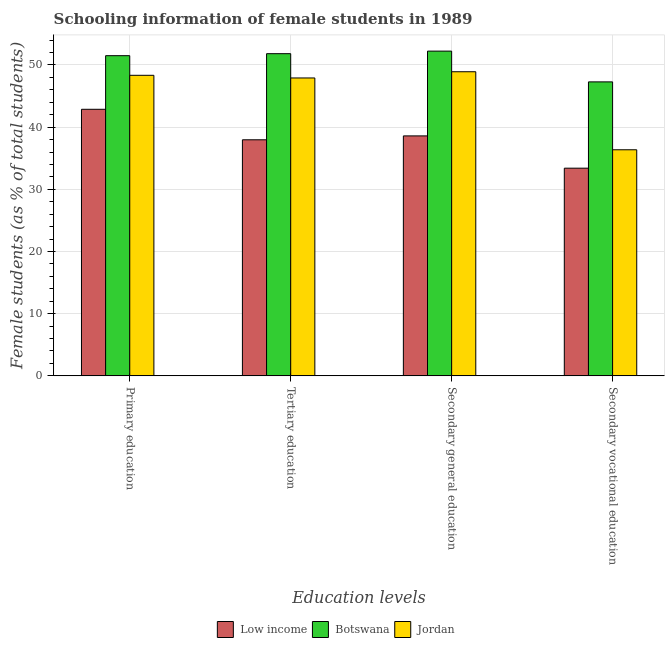How many different coloured bars are there?
Provide a short and direct response. 3. Are the number of bars per tick equal to the number of legend labels?
Offer a terse response. Yes. How many bars are there on the 1st tick from the left?
Your response must be concise. 3. How many bars are there on the 1st tick from the right?
Keep it short and to the point. 3. What is the percentage of female students in secondary education in Low income?
Offer a very short reply. 38.59. Across all countries, what is the maximum percentage of female students in secondary education?
Make the answer very short. 52.23. Across all countries, what is the minimum percentage of female students in secondary education?
Ensure brevity in your answer.  38.59. In which country was the percentage of female students in primary education maximum?
Give a very brief answer. Botswana. In which country was the percentage of female students in primary education minimum?
Your answer should be compact. Low income. What is the total percentage of female students in secondary education in the graph?
Ensure brevity in your answer.  139.73. What is the difference between the percentage of female students in primary education in Low income and that in Botswana?
Your response must be concise. -8.62. What is the difference between the percentage of female students in secondary vocational education in Botswana and the percentage of female students in primary education in Low income?
Give a very brief answer. 4.41. What is the average percentage of female students in secondary education per country?
Offer a very short reply. 46.58. What is the difference between the percentage of female students in secondary vocational education and percentage of female students in secondary education in Low income?
Your answer should be compact. -5.19. What is the ratio of the percentage of female students in secondary vocational education in Jordan to that in Low income?
Make the answer very short. 1.09. Is the percentage of female students in secondary vocational education in Botswana less than that in Jordan?
Offer a very short reply. No. What is the difference between the highest and the second highest percentage of female students in secondary vocational education?
Give a very brief answer. 10.92. What is the difference between the highest and the lowest percentage of female students in secondary vocational education?
Your response must be concise. 13.88. Is the sum of the percentage of female students in secondary education in Jordan and Botswana greater than the maximum percentage of female students in secondary vocational education across all countries?
Ensure brevity in your answer.  Yes. Is it the case that in every country, the sum of the percentage of female students in secondary education and percentage of female students in secondary vocational education is greater than the sum of percentage of female students in tertiary education and percentage of female students in primary education?
Keep it short and to the point. No. What does the 3rd bar from the left in Tertiary education represents?
Offer a very short reply. Jordan. How many countries are there in the graph?
Provide a short and direct response. 3. What is the difference between two consecutive major ticks on the Y-axis?
Offer a very short reply. 10. Does the graph contain any zero values?
Give a very brief answer. No. Does the graph contain grids?
Your answer should be very brief. Yes. Where does the legend appear in the graph?
Offer a terse response. Bottom center. How are the legend labels stacked?
Keep it short and to the point. Horizontal. What is the title of the graph?
Offer a very short reply. Schooling information of female students in 1989. Does "Djibouti" appear as one of the legend labels in the graph?
Give a very brief answer. No. What is the label or title of the X-axis?
Make the answer very short. Education levels. What is the label or title of the Y-axis?
Make the answer very short. Female students (as % of total students). What is the Female students (as % of total students) in Low income in Primary education?
Offer a very short reply. 42.87. What is the Female students (as % of total students) in Botswana in Primary education?
Offer a very short reply. 51.49. What is the Female students (as % of total students) of Jordan in Primary education?
Ensure brevity in your answer.  48.34. What is the Female students (as % of total students) of Low income in Tertiary education?
Make the answer very short. 37.97. What is the Female students (as % of total students) of Botswana in Tertiary education?
Your answer should be very brief. 51.81. What is the Female students (as % of total students) in Jordan in Tertiary education?
Your answer should be compact. 47.91. What is the Female students (as % of total students) in Low income in Secondary general education?
Provide a short and direct response. 38.59. What is the Female students (as % of total students) of Botswana in Secondary general education?
Keep it short and to the point. 52.23. What is the Female students (as % of total students) of Jordan in Secondary general education?
Ensure brevity in your answer.  48.91. What is the Female students (as % of total students) of Low income in Secondary vocational education?
Make the answer very short. 33.4. What is the Female students (as % of total students) of Botswana in Secondary vocational education?
Your answer should be very brief. 47.28. What is the Female students (as % of total students) of Jordan in Secondary vocational education?
Keep it short and to the point. 36.36. Across all Education levels, what is the maximum Female students (as % of total students) of Low income?
Make the answer very short. 42.87. Across all Education levels, what is the maximum Female students (as % of total students) in Botswana?
Keep it short and to the point. 52.23. Across all Education levels, what is the maximum Female students (as % of total students) in Jordan?
Provide a succinct answer. 48.91. Across all Education levels, what is the minimum Female students (as % of total students) in Low income?
Make the answer very short. 33.4. Across all Education levels, what is the minimum Female students (as % of total students) of Botswana?
Your response must be concise. 47.28. Across all Education levels, what is the minimum Female students (as % of total students) of Jordan?
Offer a terse response. 36.36. What is the total Female students (as % of total students) of Low income in the graph?
Your response must be concise. 152.83. What is the total Female students (as % of total students) of Botswana in the graph?
Make the answer very short. 202.81. What is the total Female students (as % of total students) in Jordan in the graph?
Give a very brief answer. 181.51. What is the difference between the Female students (as % of total students) in Low income in Primary education and that in Tertiary education?
Offer a very short reply. 4.91. What is the difference between the Female students (as % of total students) of Botswana in Primary education and that in Tertiary education?
Provide a succinct answer. -0.32. What is the difference between the Female students (as % of total students) in Jordan in Primary education and that in Tertiary education?
Make the answer very short. 0.43. What is the difference between the Female students (as % of total students) in Low income in Primary education and that in Secondary general education?
Keep it short and to the point. 4.28. What is the difference between the Female students (as % of total students) of Botswana in Primary education and that in Secondary general education?
Provide a short and direct response. -0.73. What is the difference between the Female students (as % of total students) of Jordan in Primary education and that in Secondary general education?
Make the answer very short. -0.57. What is the difference between the Female students (as % of total students) in Low income in Primary education and that in Secondary vocational education?
Provide a succinct answer. 9.47. What is the difference between the Female students (as % of total students) of Botswana in Primary education and that in Secondary vocational education?
Make the answer very short. 4.21. What is the difference between the Female students (as % of total students) in Jordan in Primary education and that in Secondary vocational education?
Give a very brief answer. 11.98. What is the difference between the Female students (as % of total students) in Low income in Tertiary education and that in Secondary general education?
Give a very brief answer. -0.63. What is the difference between the Female students (as % of total students) in Botswana in Tertiary education and that in Secondary general education?
Offer a very short reply. -0.41. What is the difference between the Female students (as % of total students) of Jordan in Tertiary education and that in Secondary general education?
Offer a very short reply. -1. What is the difference between the Female students (as % of total students) in Low income in Tertiary education and that in Secondary vocational education?
Provide a succinct answer. 4.57. What is the difference between the Female students (as % of total students) in Botswana in Tertiary education and that in Secondary vocational education?
Your answer should be compact. 4.54. What is the difference between the Female students (as % of total students) in Jordan in Tertiary education and that in Secondary vocational education?
Make the answer very short. 11.55. What is the difference between the Female students (as % of total students) in Low income in Secondary general education and that in Secondary vocational education?
Your response must be concise. 5.19. What is the difference between the Female students (as % of total students) of Botswana in Secondary general education and that in Secondary vocational education?
Your answer should be very brief. 4.95. What is the difference between the Female students (as % of total students) of Jordan in Secondary general education and that in Secondary vocational education?
Provide a short and direct response. 12.55. What is the difference between the Female students (as % of total students) of Low income in Primary education and the Female students (as % of total students) of Botswana in Tertiary education?
Provide a succinct answer. -8.94. What is the difference between the Female students (as % of total students) in Low income in Primary education and the Female students (as % of total students) in Jordan in Tertiary education?
Offer a terse response. -5.04. What is the difference between the Female students (as % of total students) in Botswana in Primary education and the Female students (as % of total students) in Jordan in Tertiary education?
Ensure brevity in your answer.  3.58. What is the difference between the Female students (as % of total students) of Low income in Primary education and the Female students (as % of total students) of Botswana in Secondary general education?
Ensure brevity in your answer.  -9.35. What is the difference between the Female students (as % of total students) in Low income in Primary education and the Female students (as % of total students) in Jordan in Secondary general education?
Make the answer very short. -6.04. What is the difference between the Female students (as % of total students) in Botswana in Primary education and the Female students (as % of total students) in Jordan in Secondary general education?
Provide a short and direct response. 2.58. What is the difference between the Female students (as % of total students) of Low income in Primary education and the Female students (as % of total students) of Botswana in Secondary vocational education?
Provide a short and direct response. -4.41. What is the difference between the Female students (as % of total students) in Low income in Primary education and the Female students (as % of total students) in Jordan in Secondary vocational education?
Your answer should be very brief. 6.51. What is the difference between the Female students (as % of total students) in Botswana in Primary education and the Female students (as % of total students) in Jordan in Secondary vocational education?
Your answer should be compact. 15.13. What is the difference between the Female students (as % of total students) in Low income in Tertiary education and the Female students (as % of total students) in Botswana in Secondary general education?
Keep it short and to the point. -14.26. What is the difference between the Female students (as % of total students) of Low income in Tertiary education and the Female students (as % of total students) of Jordan in Secondary general education?
Make the answer very short. -10.94. What is the difference between the Female students (as % of total students) of Botswana in Tertiary education and the Female students (as % of total students) of Jordan in Secondary general education?
Ensure brevity in your answer.  2.9. What is the difference between the Female students (as % of total students) in Low income in Tertiary education and the Female students (as % of total students) in Botswana in Secondary vocational education?
Your answer should be very brief. -9.31. What is the difference between the Female students (as % of total students) in Low income in Tertiary education and the Female students (as % of total students) in Jordan in Secondary vocational education?
Provide a succinct answer. 1.6. What is the difference between the Female students (as % of total students) of Botswana in Tertiary education and the Female students (as % of total students) of Jordan in Secondary vocational education?
Give a very brief answer. 15.45. What is the difference between the Female students (as % of total students) of Low income in Secondary general education and the Female students (as % of total students) of Botswana in Secondary vocational education?
Your answer should be very brief. -8.69. What is the difference between the Female students (as % of total students) of Low income in Secondary general education and the Female students (as % of total students) of Jordan in Secondary vocational education?
Give a very brief answer. 2.23. What is the difference between the Female students (as % of total students) in Botswana in Secondary general education and the Female students (as % of total students) in Jordan in Secondary vocational education?
Offer a very short reply. 15.87. What is the average Female students (as % of total students) of Low income per Education levels?
Your answer should be very brief. 38.21. What is the average Female students (as % of total students) of Botswana per Education levels?
Your answer should be compact. 50.7. What is the average Female students (as % of total students) of Jordan per Education levels?
Offer a terse response. 45.38. What is the difference between the Female students (as % of total students) in Low income and Female students (as % of total students) in Botswana in Primary education?
Provide a succinct answer. -8.62. What is the difference between the Female students (as % of total students) in Low income and Female students (as % of total students) in Jordan in Primary education?
Provide a succinct answer. -5.46. What is the difference between the Female students (as % of total students) in Botswana and Female students (as % of total students) in Jordan in Primary education?
Give a very brief answer. 3.16. What is the difference between the Female students (as % of total students) of Low income and Female students (as % of total students) of Botswana in Tertiary education?
Give a very brief answer. -13.85. What is the difference between the Female students (as % of total students) in Low income and Female students (as % of total students) in Jordan in Tertiary education?
Provide a succinct answer. -9.94. What is the difference between the Female students (as % of total students) of Botswana and Female students (as % of total students) of Jordan in Tertiary education?
Offer a terse response. 3.9. What is the difference between the Female students (as % of total students) in Low income and Female students (as % of total students) in Botswana in Secondary general education?
Ensure brevity in your answer.  -13.64. What is the difference between the Female students (as % of total students) in Low income and Female students (as % of total students) in Jordan in Secondary general education?
Offer a very short reply. -10.32. What is the difference between the Female students (as % of total students) of Botswana and Female students (as % of total students) of Jordan in Secondary general education?
Offer a very short reply. 3.32. What is the difference between the Female students (as % of total students) of Low income and Female students (as % of total students) of Botswana in Secondary vocational education?
Make the answer very short. -13.88. What is the difference between the Female students (as % of total students) of Low income and Female students (as % of total students) of Jordan in Secondary vocational education?
Your answer should be very brief. -2.96. What is the difference between the Female students (as % of total students) in Botswana and Female students (as % of total students) in Jordan in Secondary vocational education?
Provide a succinct answer. 10.92. What is the ratio of the Female students (as % of total students) of Low income in Primary education to that in Tertiary education?
Make the answer very short. 1.13. What is the ratio of the Female students (as % of total students) in Botswana in Primary education to that in Tertiary education?
Provide a short and direct response. 0.99. What is the ratio of the Female students (as % of total students) in Jordan in Primary education to that in Tertiary education?
Offer a terse response. 1.01. What is the ratio of the Female students (as % of total students) of Low income in Primary education to that in Secondary general education?
Keep it short and to the point. 1.11. What is the ratio of the Female students (as % of total students) of Botswana in Primary education to that in Secondary general education?
Provide a succinct answer. 0.99. What is the ratio of the Female students (as % of total students) of Jordan in Primary education to that in Secondary general education?
Make the answer very short. 0.99. What is the ratio of the Female students (as % of total students) of Low income in Primary education to that in Secondary vocational education?
Keep it short and to the point. 1.28. What is the ratio of the Female students (as % of total students) in Botswana in Primary education to that in Secondary vocational education?
Make the answer very short. 1.09. What is the ratio of the Female students (as % of total students) of Jordan in Primary education to that in Secondary vocational education?
Provide a succinct answer. 1.33. What is the ratio of the Female students (as % of total students) in Low income in Tertiary education to that in Secondary general education?
Ensure brevity in your answer.  0.98. What is the ratio of the Female students (as % of total students) in Jordan in Tertiary education to that in Secondary general education?
Keep it short and to the point. 0.98. What is the ratio of the Female students (as % of total students) in Low income in Tertiary education to that in Secondary vocational education?
Ensure brevity in your answer.  1.14. What is the ratio of the Female students (as % of total students) of Botswana in Tertiary education to that in Secondary vocational education?
Your response must be concise. 1.1. What is the ratio of the Female students (as % of total students) in Jordan in Tertiary education to that in Secondary vocational education?
Your answer should be compact. 1.32. What is the ratio of the Female students (as % of total students) in Low income in Secondary general education to that in Secondary vocational education?
Offer a very short reply. 1.16. What is the ratio of the Female students (as % of total students) of Botswana in Secondary general education to that in Secondary vocational education?
Provide a succinct answer. 1.1. What is the ratio of the Female students (as % of total students) of Jordan in Secondary general education to that in Secondary vocational education?
Your answer should be compact. 1.35. What is the difference between the highest and the second highest Female students (as % of total students) of Low income?
Offer a very short reply. 4.28. What is the difference between the highest and the second highest Female students (as % of total students) in Botswana?
Keep it short and to the point. 0.41. What is the difference between the highest and the second highest Female students (as % of total students) of Jordan?
Make the answer very short. 0.57. What is the difference between the highest and the lowest Female students (as % of total students) in Low income?
Your answer should be compact. 9.47. What is the difference between the highest and the lowest Female students (as % of total students) of Botswana?
Ensure brevity in your answer.  4.95. What is the difference between the highest and the lowest Female students (as % of total students) in Jordan?
Your answer should be very brief. 12.55. 